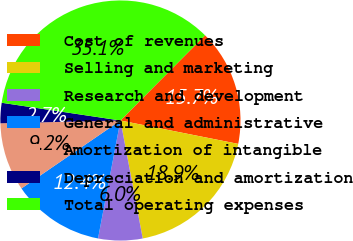<chart> <loc_0><loc_0><loc_500><loc_500><pie_chart><fcel>Cost of revenues<fcel>Selling and marketing<fcel>Research and development<fcel>General and administrative<fcel>Amortization of intangible<fcel>Depreciation and amortization<fcel>Total operating expenses<nl><fcel>15.67%<fcel>18.91%<fcel>5.96%<fcel>12.44%<fcel>9.2%<fcel>2.73%<fcel>35.09%<nl></chart> 